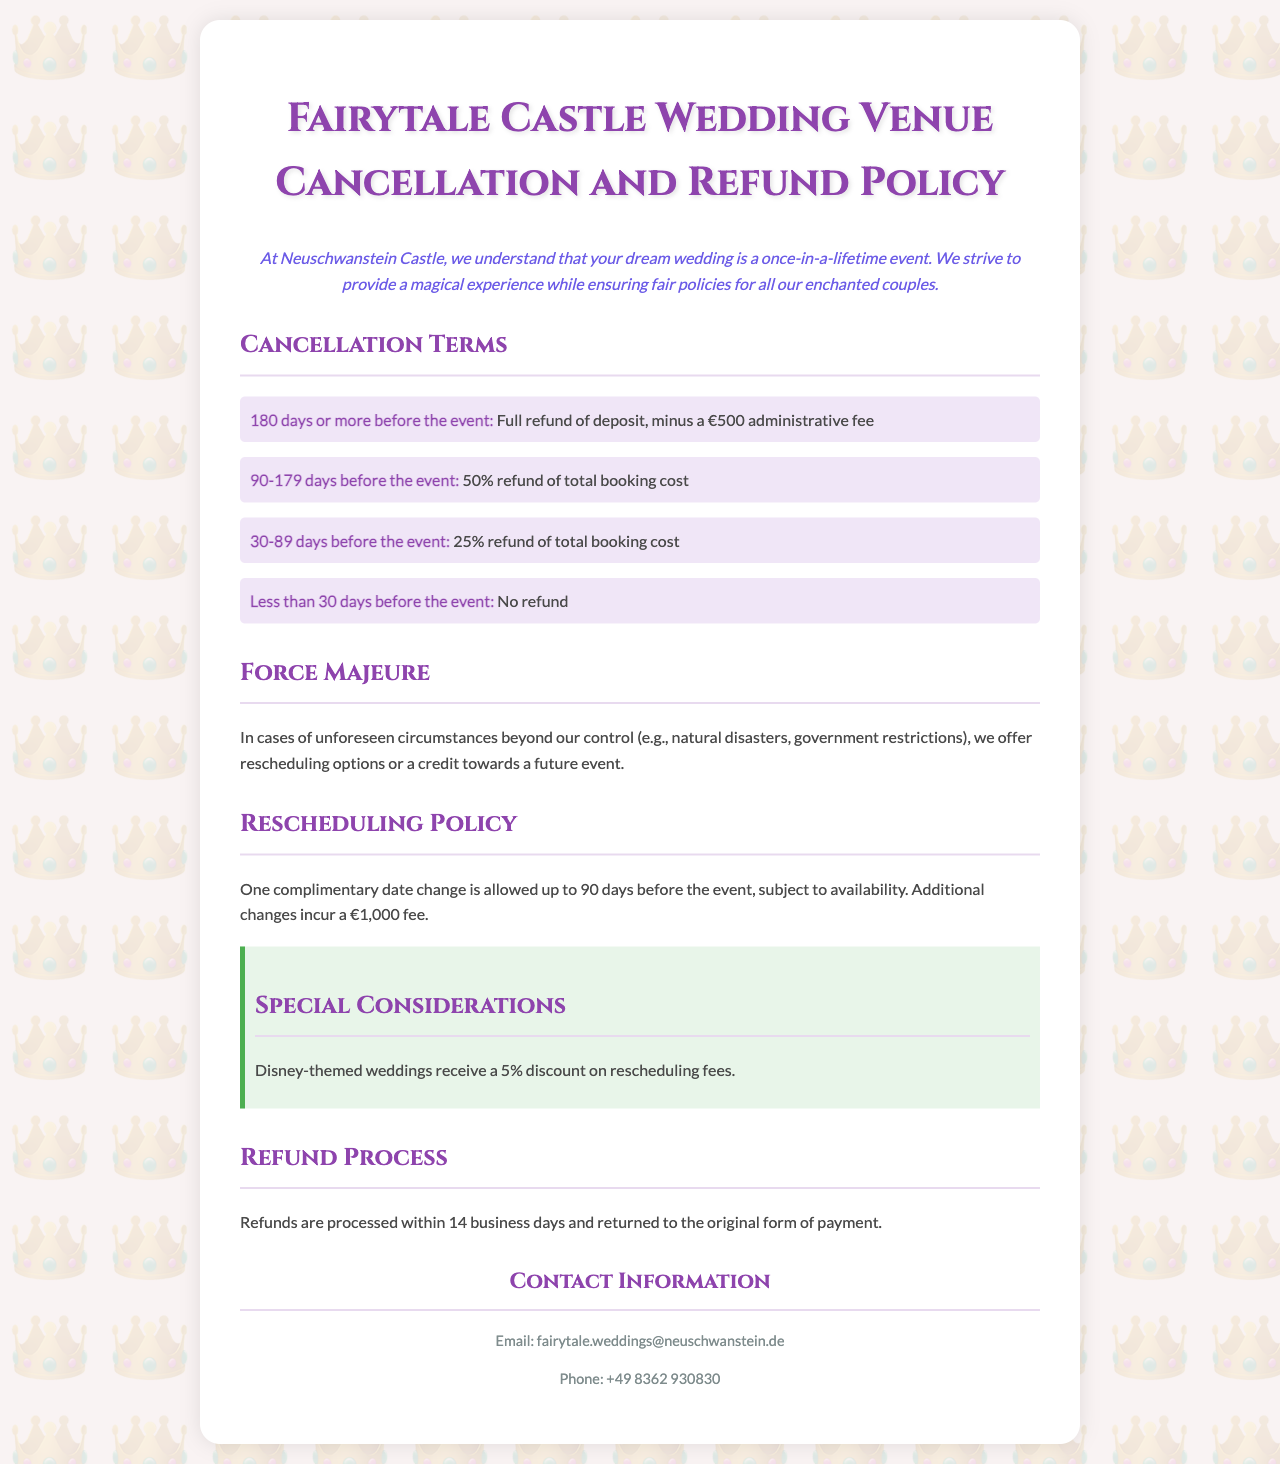What is the administrative fee for cancellations 180 days or more before the event? The document states that the administrative fee is €500 for cancellations made 180 days or more before the event.
Answer: €500 What is the percentage refund for cancellations 90-179 days before the event? The document indicates that a 50% refund of the total booking cost is offered for cancellations made 90-179 days before the event.
Answer: 50% How many days before the event can one reschedule their wedding date without a fee? According to the policy, one complimentary date change is allowed up to 90 days before the event.
Answer: 90 days What is the refund processing time stated in the document? The document specifies that refunds are processed within 14 business days.
Answer: 14 business days What discount do Disney-themed weddings receive on rescheduling fees? The document states that Disney-themed weddings receive a 5% discount on rescheduling fees.
Answer: 5% What happens in cases of force majeure? The document explains that in cases of unforeseen circumstances, there are options for rescheduling or receiving credit towards a future event.
Answer: Rescheduling options or credit What is the refund percentage for cancellations made less than 30 days before the event? The document clearly states that there is no refund for cancellations made less than 30 days before the event.
Answer: No refund How many additional changes are allowed after the complimentary date change? The policy indicates that additional changes incur a fee of €1,000, suggesting that only one complimentary change is allowed.
Answer: One What is the contact email for inquiries? The document provides the email as fairytale.weddings@neuschwanstein.de for contact inquiries.
Answer: fairytale.weddings@neuschwanstein.de 